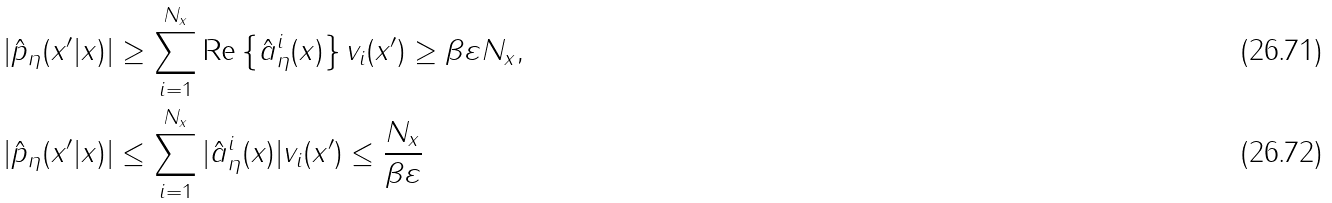Convert formula to latex. <formula><loc_0><loc_0><loc_500><loc_500>& | \hat { p } _ { \eta } ( x ^ { \prime } | x ) | \geq \sum _ { i = 1 } ^ { N _ { x } } \text {Re} \left \{ \hat { a } _ { \eta } ^ { i } ( x ) \right \} v _ { i } ( x ^ { \prime } ) \geq \beta \varepsilon N _ { x } , \\ & | \hat { p } _ { \eta } ( x ^ { \prime } | x ) | \leq \sum _ { i = 1 } ^ { N _ { x } } | \hat { a } _ { \eta } ^ { i } ( x ) | v _ { i } ( x ^ { \prime } ) \leq \frac { N _ { x } } { \beta \varepsilon }</formula> 